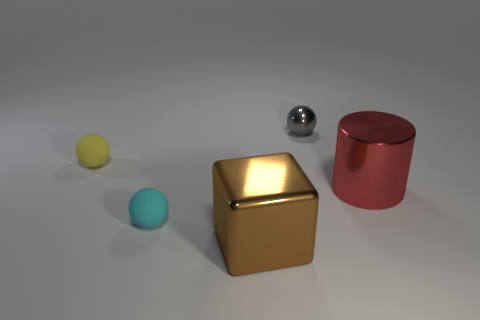Subtract all metal spheres. How many spheres are left? 2 Subtract all brown balls. Subtract all green cylinders. How many balls are left? 3 Subtract all red cubes. How many gray spheres are left? 1 Subtract all tiny red cylinders. Subtract all large brown shiny cubes. How many objects are left? 4 Add 2 tiny objects. How many tiny objects are left? 5 Add 2 large purple shiny cubes. How many large purple shiny cubes exist? 2 Add 2 red things. How many objects exist? 7 Subtract all cyan balls. How many balls are left? 2 Subtract 0 gray cylinders. How many objects are left? 5 Subtract all cubes. How many objects are left? 4 